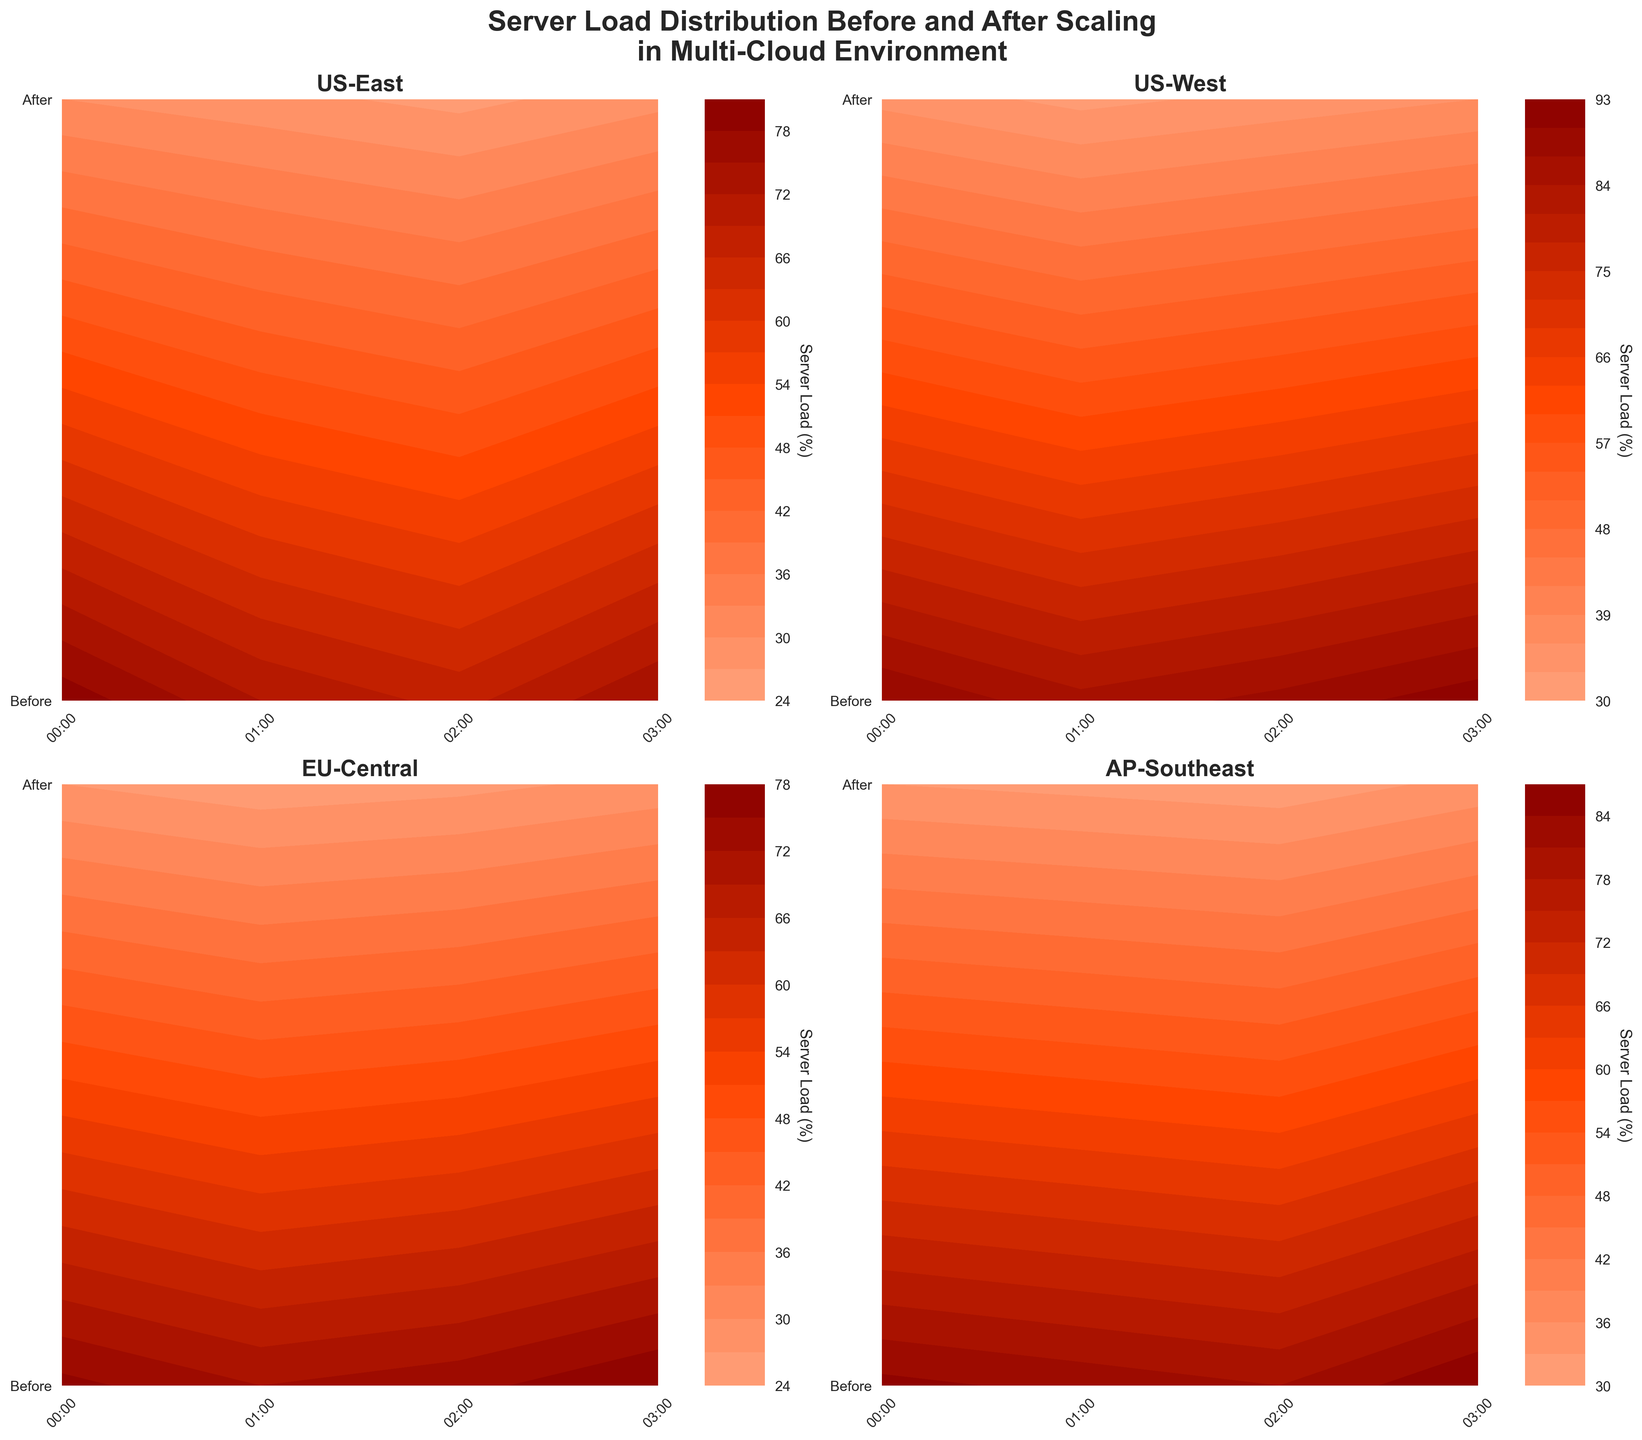What is the title of the figure? The title is usually found at the top of the figure. In this case, it reads "Server Load Distribution Before and After Scaling in Multi-Cloud Environment" as given in the plotting code.
Answer: Server Load Distribution Before and After Scaling in Multi-Cloud Environment How many nodes' data are visualized in the figure? By counting the number of individual subplot titles such as 'US-East', 'US-West', 'EU-Central', and 'AP-Southeast', we see that data for four nodes are visualized.
Answer: Four Which node had the highest server load before scaling at 03:00? By examining the 'Before' row for the timestamp 03:00 in each subplot, the 'US-West' node had the highest load of 92.
Answer: US-West Did the server load in 'EU-Central' reduce by more than 50% after scaling at 00:00? Before scaling, the server load was 76, and after scaling, it was 27. To check the reduction: (76 - 27) / 76 = 0.64, which is more than 50%.
Answer: Yes Compare the load reduction percentage between 'US-East' and 'AP-Southeast' nodes at 02:00. Which had a higher reduction? For 'US-East' at 02:00: (68 - 26) / 68 = 0.6176 (61.76%). For 'AP-Southeast' at 02:00: (81 - 31) / 81 = 0.6173 (61.73%). So, 'US-East' had a slightly higher reduction.
Answer: US-East What is the color range used to indicate server load on the plots? The color range transitions from light salmon to red to dark red, indicating increasing server load. The labeled color bar gives a visual cue.
Answer: Light salmon to dark red Which node shows the smallest difference in server load before and after scaling at 01:00? Comparing the differences: 'US-East' (72-28=44), 'US-West' (85-32=53), 'EU-Central' (72-25=47), 'AP-Southeast' (83-32=51). 'US-East' has the smallest difference of 44.
Answer: US-East How does the contour plot visually represent different server loads? The contour plot uses color gradients where more intense (darker) colors represent higher server loads, and lighter colors represent lower loads.
Answer: Color gradients Which node has the largest load at 01:00 after scaling? Checking the 'After' row for the timestamp 01:00 in each subplot: 'US-East' (28), 'US-West' (32), 'EU-Central' (25), 'AP-Southeast' (32), 'US-West' and 'AP-Southeast' both have the highest load of 32.
Answer: Tie between US-West and AP-Southeast 